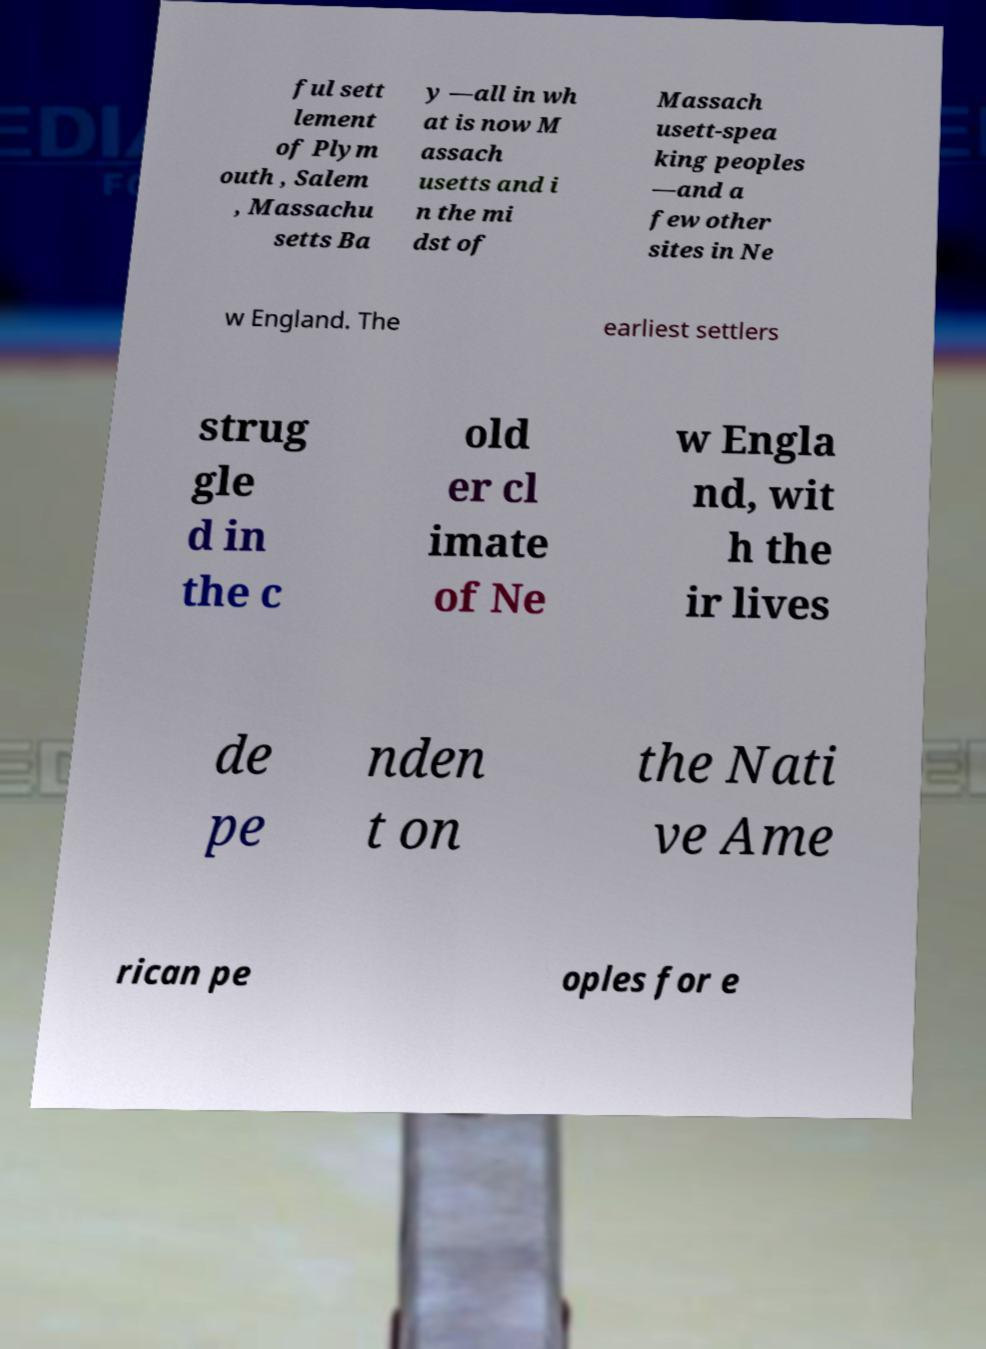Could you assist in decoding the text presented in this image and type it out clearly? ful sett lement of Plym outh , Salem , Massachu setts Ba y —all in wh at is now M assach usetts and i n the mi dst of Massach usett-spea king peoples —and a few other sites in Ne w England. The earliest settlers strug gle d in the c old er cl imate of Ne w Engla nd, wit h the ir lives de pe nden t on the Nati ve Ame rican pe oples for e 